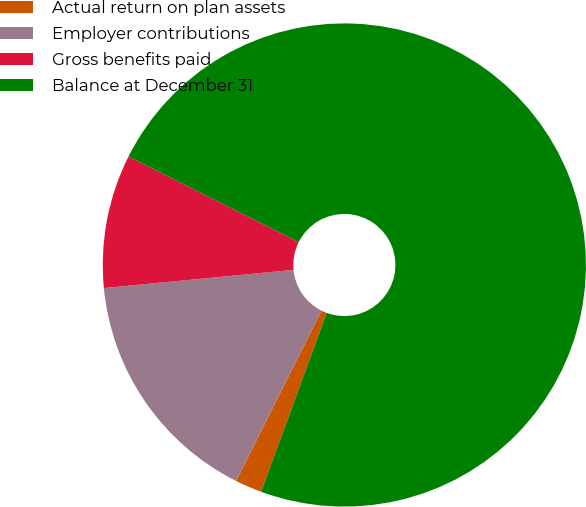Convert chart to OTSL. <chart><loc_0><loc_0><loc_500><loc_500><pie_chart><fcel>Actual return on plan assets<fcel>Employer contributions<fcel>Gross benefits paid<fcel>Balance at December 31<nl><fcel>1.8%<fcel>16.08%<fcel>8.94%<fcel>73.18%<nl></chart> 